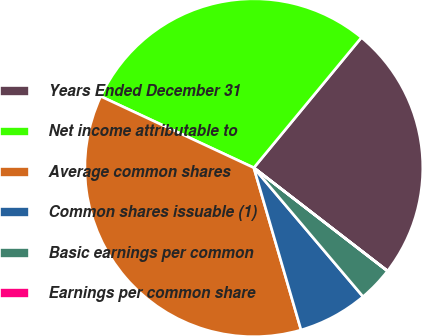Convert chart. <chart><loc_0><loc_0><loc_500><loc_500><pie_chart><fcel>Years Ended December 31<fcel>Net income attributable to<fcel>Average common shares<fcel>Common shares issuable (1)<fcel>Basic earnings per common<fcel>Earnings per common share<nl><fcel>24.47%<fcel>29.04%<fcel>36.45%<fcel>6.68%<fcel>3.34%<fcel>0.01%<nl></chart> 